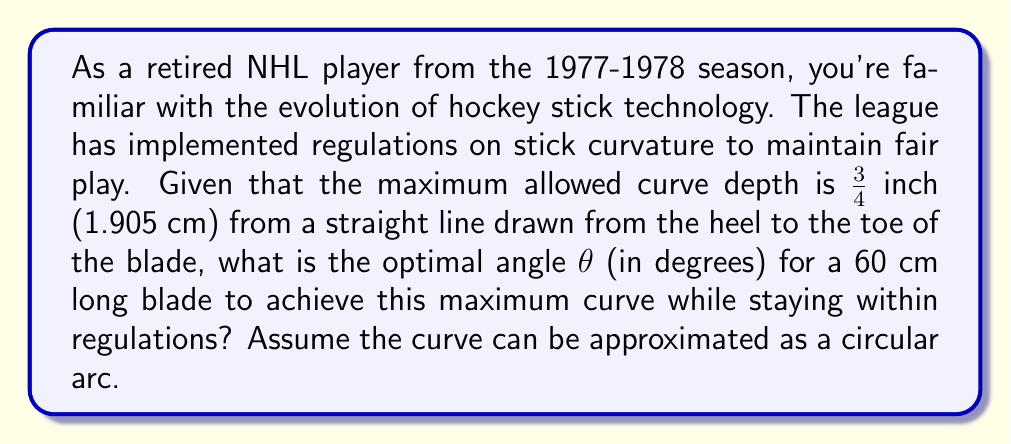Help me with this question. To solve this problem, we'll use the properties of a circular arc and basic trigonometry.

1) Let's consider the blade as a chord of a circle, with the curve being an arc of that circle.

2) The curve depth (h) is the distance from the midpoint of the chord to the arc. This forms a right triangle with half of the blade length and the circle's radius.

3) Given:
   - Blade length (L) = 60 cm
   - Maximum curve depth (h) = 1.905 cm

4) Let's denote the radius of the circle as R. Using the Pythagorean theorem:

   $$(R-h)^2 + (\frac{L}{2})^2 = R^2$$

5) Expanding this equation:

   $$R^2 - 2Rh + h^2 + (\frac{L}{2})^2 = R^2$$

6) Simplifying:

   $$-2Rh + h^2 + (\frac{L}{2})^2 = 0$$

7) Solving for R:

   $$R = \frac{h^2 + (\frac{L}{2})^2}{2h}$$

8) Substituting the values:

   $$R = \frac{(1.905)^2 + (30)^2}{2(1.905)} \approx 236.85 \text{ cm}$$

9) Now, we can find the central angle $\theta$ using the arc length formula:

   $$L = R\theta$$ (where $\theta$ is in radians)

10) Solving for $\theta$:

    $$\theta = \frac{L}{R} = \frac{60}{236.85} \approx 0.2533 \text{ radians}$$

11) Converting to degrees:

    $$\theta \approx 0.2533 \times \frac{180}{\pi} \approx 14.52°$$

This angle represents the optimal curve for maximum depth within regulations.
Answer: The optimal angle for the hockey stick curve is approximately $14.52°$. 